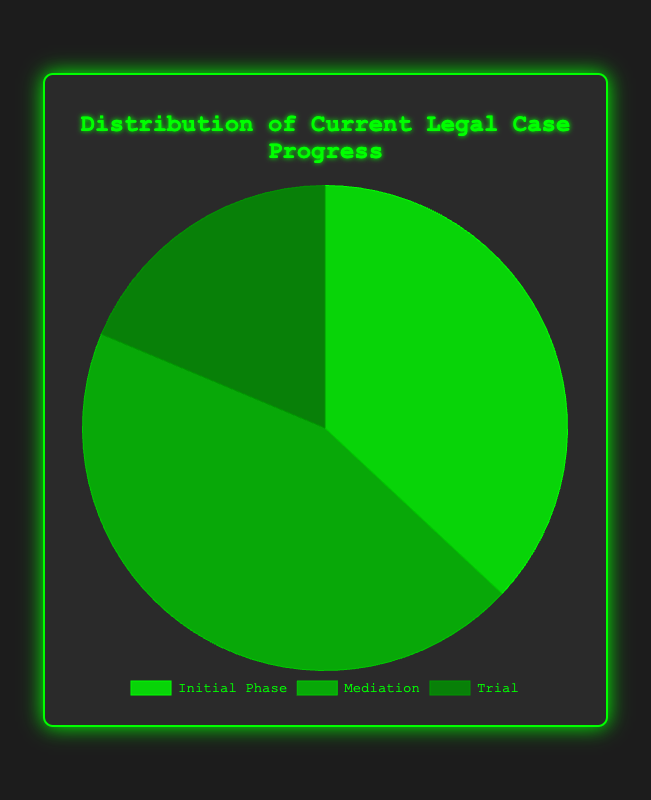What's the total number of cases in the "Mediation" phase? The "Mediation" phase consists of 33 (High Tech Corp) + 27 (Fintech Startup) + 24 (Cryptocurrency Exchange) + 30 (Social Media Enterprise). Summing these values, we get 114.
Answer: 114 Which phase has the fewest total cases across all types? Looking at the total cases: Initial Phase (18 + 22 + 30 + 25 = 95), Mediation (33 + 27 + 24 + 30 = 114), and Trial (11 + 15 + 10 + 12 = 48). The Trial phase has the fewest with 48.
Answer: Trial How many more cases are in the "Initial Phase" compared to the "Trial" phase? The total cases in Initial Phase are 95, and in the Trial phase, they are 48. Subtracting these values gives 95 - 48 = 47 more cases.
Answer: 47 What percentage of total cases are in the "Trial" phase? There are 95 cases in the Initial Phase, 114 in Mediation, and 48 in Trial. The total number of cases is 95 + 114 + 48 = 257. The percentage is (48/257) * 100 ≈ 18.68%.
Answer: 18.68% What is the total number of "Securities Fraud - High Tech Corp" cases? Adding up the cases for "High Tech Corp": Initial Phase (18), Mediation (33), and Trial (11). The total is 18 + 33 + 11 = 62.
Answer: 62 Which case type has the most cases in the "Initial Phase"? Comparing the Initial Phase cases: High Tech Corp (18), Fintech Startup (22), Cryptocurrency Exchange (30), and Social Media Enterprise (25). Cryptocurrency Exchange has the most with 30.
Answer: Cryptocurrency Exchange What is the average number of cases in the "Trial" phase for all case types? Adding the Trial cases: 11 (High Tech Corp), 15 (Fintech Startup), 10 (Cryptocurrency Exchange), and 12 (Social Media Enterprise). The total is 48. The average is 48/4 = 12.
Answer: 12 How does the number of "Mediation" cases for "Fintech Startup" compare to the number of "Trial" cases for "High Tech Corp"? Fintech Startup has 27 Mediation cases, and High Tech Corp has 11 Trial cases. 27 is greater than 11.
Answer: Greater What are the three colors used in the pie chart to represent the phases? The chart uses variations of green: a bright green, a medium green, and a dark green.
Answer: Bright green, medium green, dark green Which phase is represented by the dark green color in the pie chart? By referencing the data, the Trial phase has the least number of cases, so it's likely represented by the darkest color.
Answer: Trial 